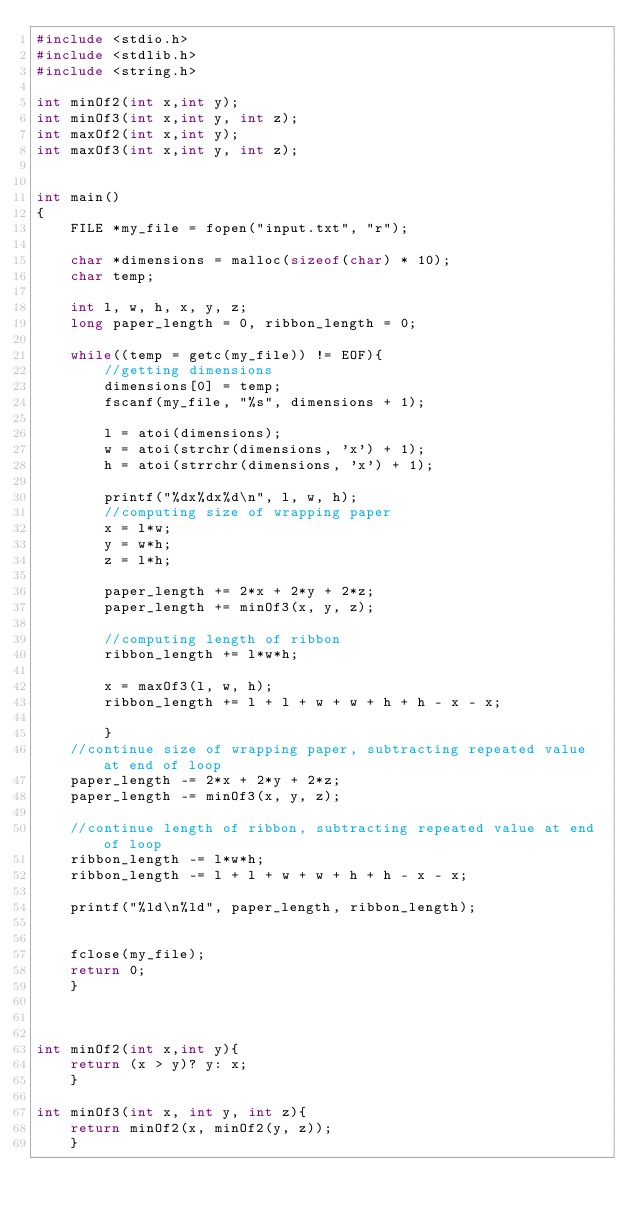Convert code to text. <code><loc_0><loc_0><loc_500><loc_500><_C_>#include <stdio.h>
#include <stdlib.h>
#include <string.h>

int minOf2(int x,int y);
int minOf3(int x,int y, int z);
int maxOf2(int x,int y);
int maxOf3(int x,int y, int z);


int main()
{
    FILE *my_file = fopen("input.txt", "r");

    char *dimensions = malloc(sizeof(char) * 10);
    char temp;

    int l, w, h, x, y, z;
    long paper_length = 0, ribbon_length = 0;

    while((temp = getc(my_file)) != EOF){
        //getting dimensions
        dimensions[0] = temp;
        fscanf(my_file, "%s", dimensions + 1);

        l = atoi(dimensions);
        w = atoi(strchr(dimensions, 'x') + 1);
        h = atoi(strrchr(dimensions, 'x') + 1);

        printf("%dx%dx%d\n", l, w, h);
        //computing size of wrapping paper
        x = l*w;
        y = w*h;
        z = l*h;

        paper_length += 2*x + 2*y + 2*z;
        paper_length += minOf3(x, y, z);

        //computing length of ribbon
        ribbon_length += l*w*h;

        x = maxOf3(l, w, h);
        ribbon_length += l + l + w + w + h + h - x - x;

        }
    //continue size of wrapping paper, subtracting repeated value at end of loop
    paper_length -= 2*x + 2*y + 2*z;
    paper_length -= minOf3(x, y, z);

    //continue length of ribbon, subtracting repeated value at end of loop
    ribbon_length -= l*w*h;
    ribbon_length -= l + l + w + w + h + h - x - x;

    printf("%ld\n%ld", paper_length, ribbon_length);


    fclose(my_file);
    return 0;
    }



int minOf2(int x,int y){
    return (x > y)? y: x;
    }

int minOf3(int x, int y, int z){
    return minOf2(x, minOf2(y, z));
    }
</code> 